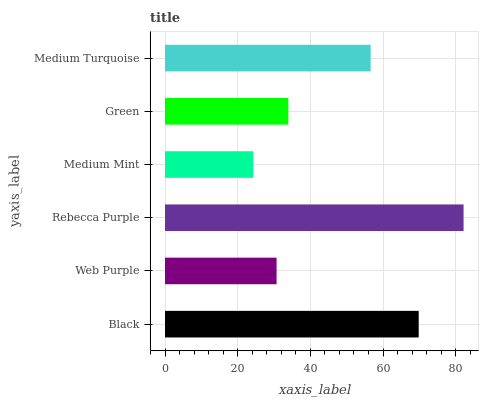Is Medium Mint the minimum?
Answer yes or no. Yes. Is Rebecca Purple the maximum?
Answer yes or no. Yes. Is Web Purple the minimum?
Answer yes or no. No. Is Web Purple the maximum?
Answer yes or no. No. Is Black greater than Web Purple?
Answer yes or no. Yes. Is Web Purple less than Black?
Answer yes or no. Yes. Is Web Purple greater than Black?
Answer yes or no. No. Is Black less than Web Purple?
Answer yes or no. No. Is Medium Turquoise the high median?
Answer yes or no. Yes. Is Green the low median?
Answer yes or no. Yes. Is Medium Mint the high median?
Answer yes or no. No. Is Medium Turquoise the low median?
Answer yes or no. No. 